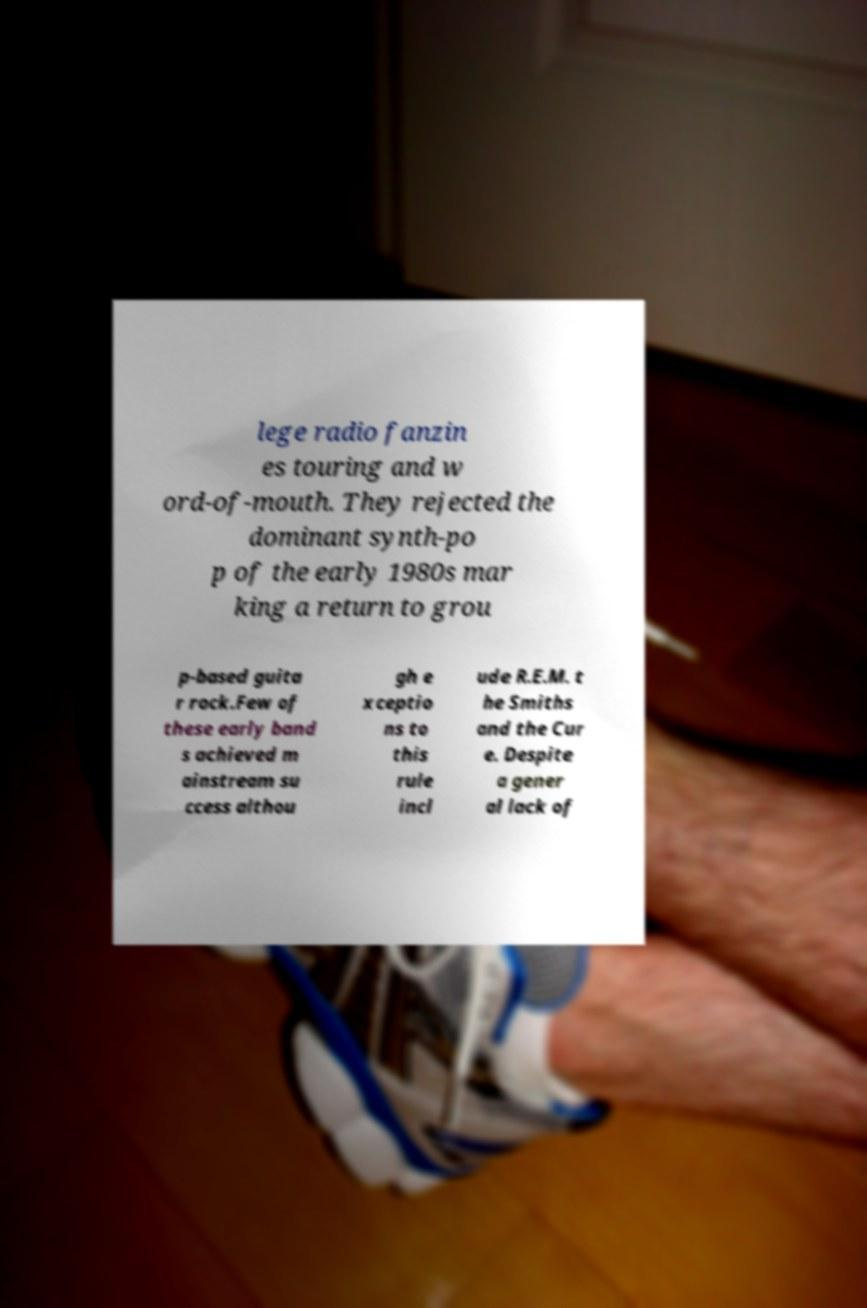Could you extract and type out the text from this image? lege radio fanzin es touring and w ord-of-mouth. They rejected the dominant synth-po p of the early 1980s mar king a return to grou p-based guita r rock.Few of these early band s achieved m ainstream su ccess althou gh e xceptio ns to this rule incl ude R.E.M. t he Smiths and the Cur e. Despite a gener al lack of 